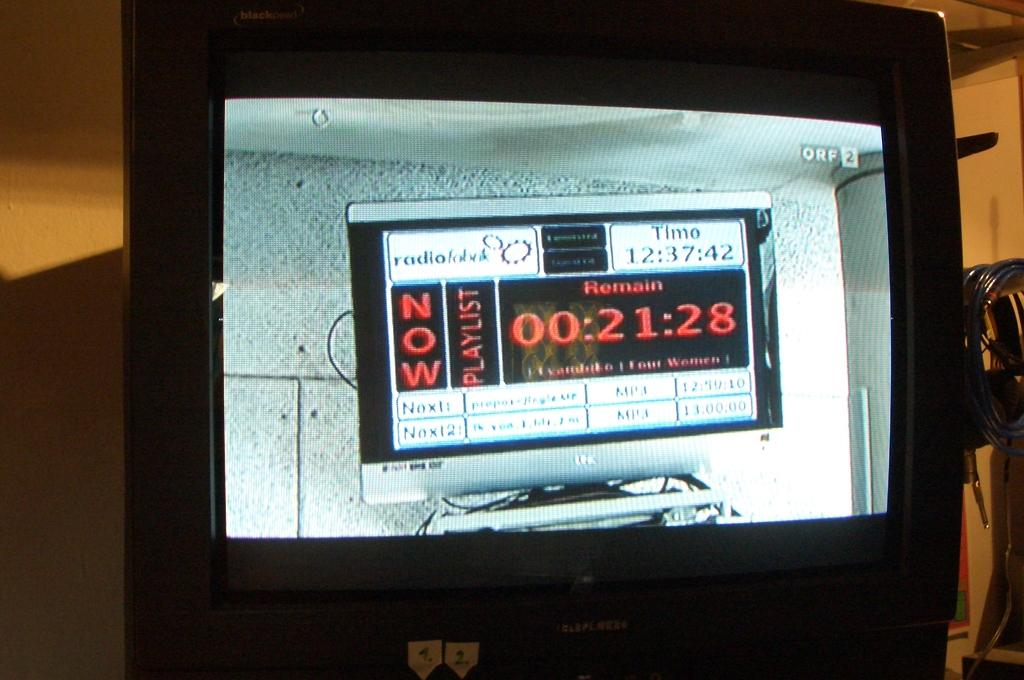<image>
Create a compact narrative representing the image presented. Television that shows a time for the now playlist radio 